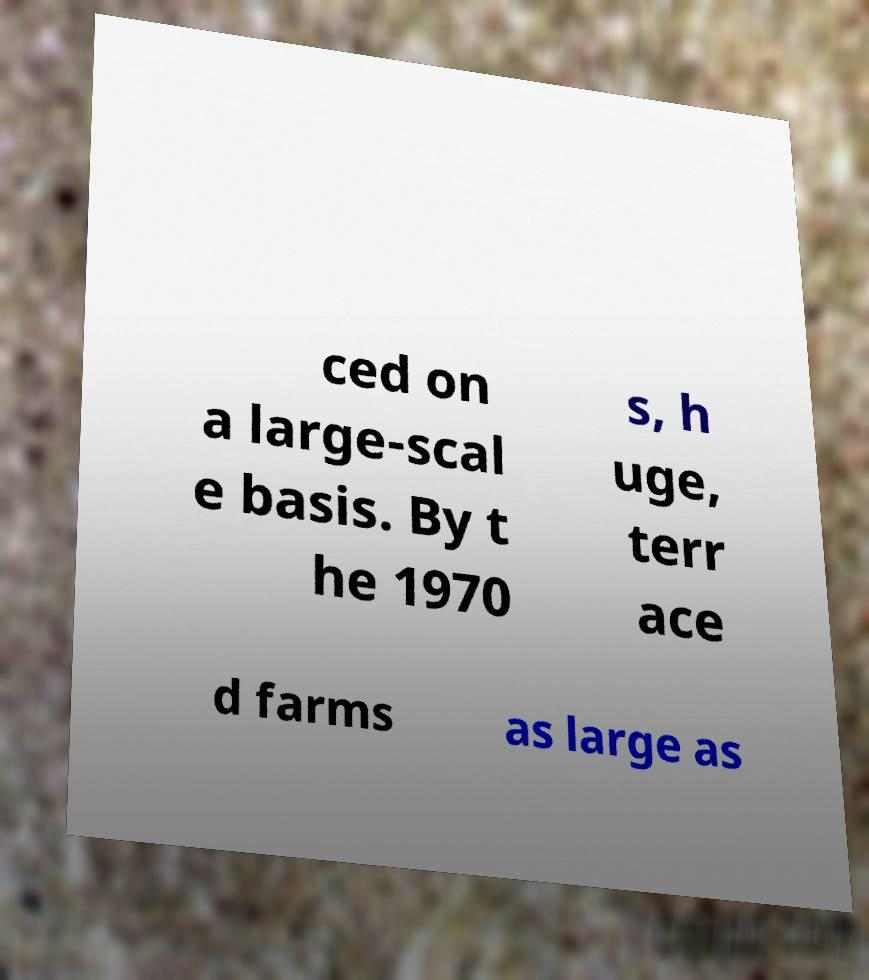There's text embedded in this image that I need extracted. Can you transcribe it verbatim? ced on a large-scal e basis. By t he 1970 s, h uge, terr ace d farms as large as 